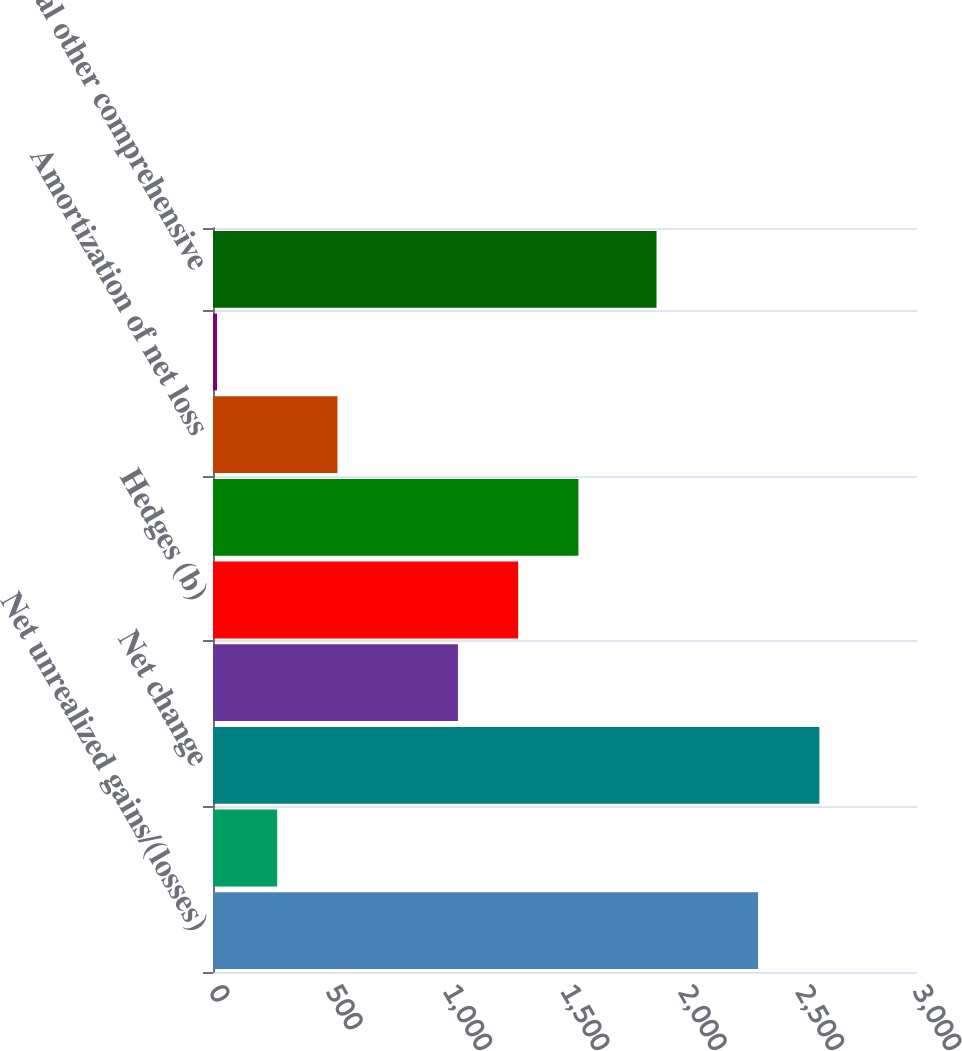<chart> <loc_0><loc_0><loc_500><loc_500><bar_chart><fcel>Net unrealized gains/(losses)<fcel>Reclassification adjustment<fcel>Net change<fcel>Translation (b)<fcel>Hedges (b)<fcel>Net gains/(losses) arising<fcel>Amortization of net loss<fcel>Prior service costs/(credits)<fcel>Total other comprehensive<nl><fcel>2323<fcel>273.7<fcel>2584<fcel>1043.8<fcel>1300.5<fcel>1557.2<fcel>530.4<fcel>17<fcel>1890<nl></chart> 